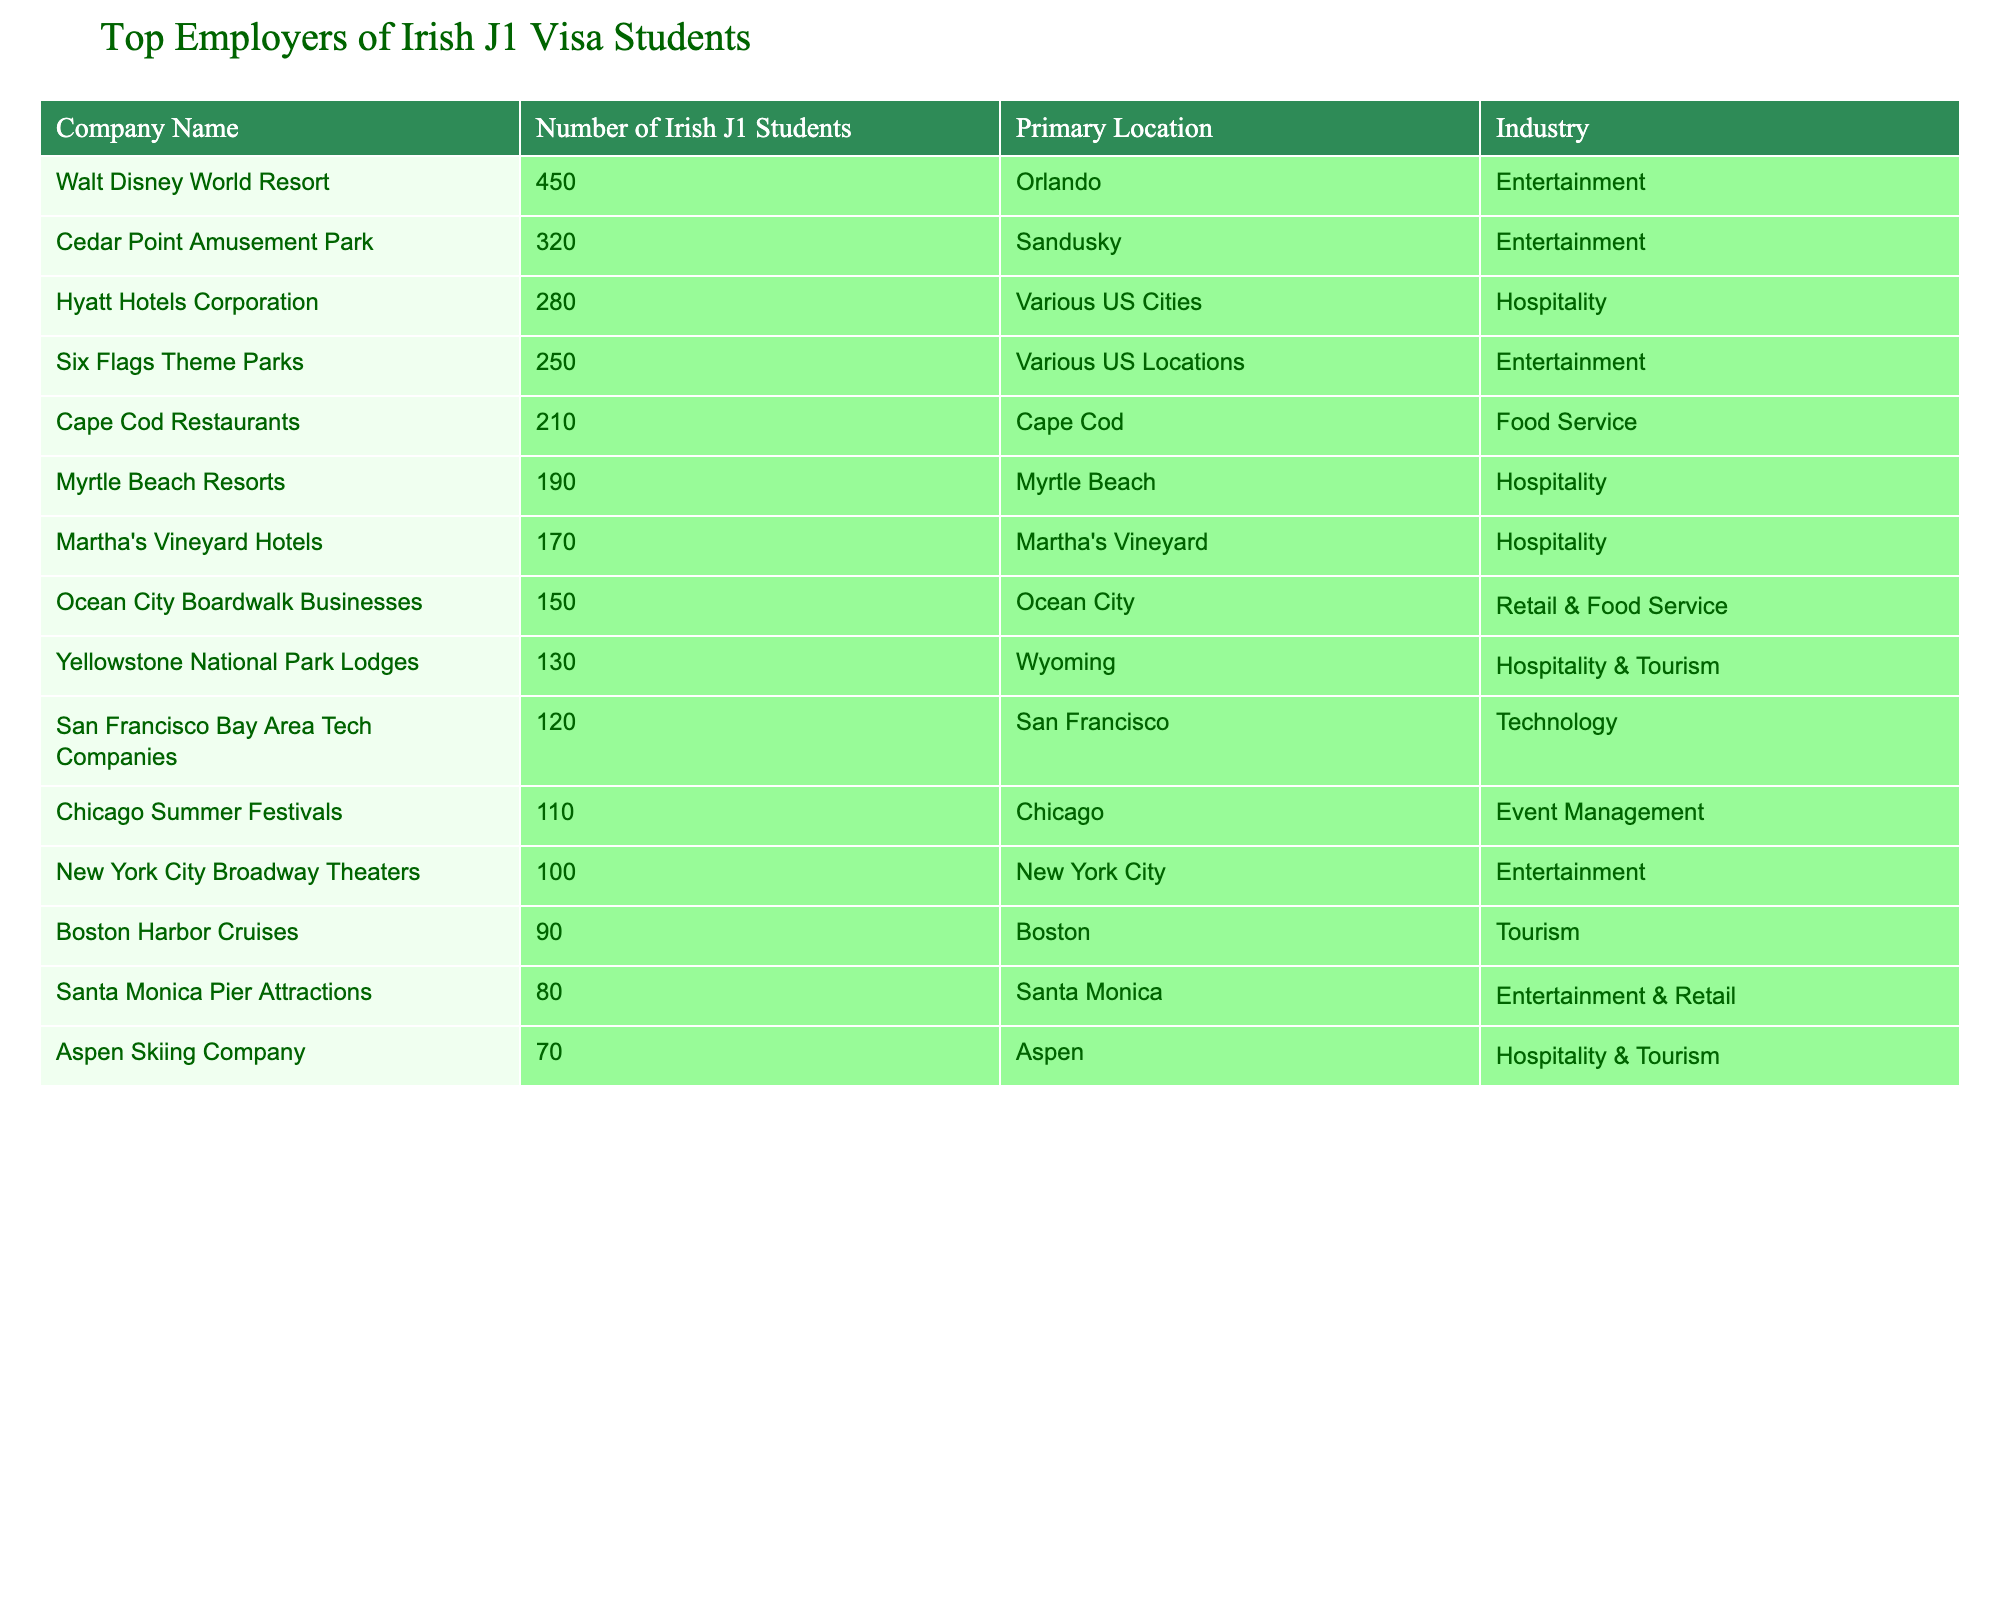What is the company with the highest number of Irish J1 students? The table shows that Walt Disney World Resort has the highest number of Irish J1 students, with a total of 450.
Answer: Walt Disney World Resort Which company is located in San Francisco? According to the table, the company located in San Francisco is San Francisco Bay Area Tech Companies, which employs 120 Irish J1 students.
Answer: San Francisco Bay Area Tech Companies How many Irish J1 students are employed by Cedar Point Amusement Park? The table lists Cedar Point Amusement Park with 320 Irish J1 students.
Answer: 320 What is the total number of J1 students from Ireland employed by the hospitality industry? The hospitality industry includes Hyatt Hotels Corporation, Myrtle Beach Resorts, Martha's Vineyard Hotels, Yellowstone National Park Lodges, and Aspen Skiing Company. Summing them gives 280 + 190 + 170 + 130 + 70 = 840.
Answer: 840 Are there more J1 students in entertainment or hospitality? Entertainment has a total of 450 + 320 + 250 + 100 + 80 = 1200 J1 students, while hospitality has 840 J1 students. Since 1200 is greater than 840, entertainment has more J1 students.
Answer: Yes, entertainment has more J1 students What percentage of the total J1 students in the table are from Walt Disney World Resort? The total number of J1 students is 450 + 320 + 280 + 250 + 210 + 190 + 170 + 150 + 130 + 120 + 110 + 100 + 90 + 80 + 70 = 2,330. The percentage from Walt Disney World Resort is (450/2330) * 100 ≈ 19.31%.
Answer: Approximately 19.31% Which industry has the least number of Irish J1 students, and how many are there? By analyzing the numbers, Aspen Skiing Company, located in the hospitality & tourism industry, has the least number of J1 students with 70.
Answer: Hospitality & Tourism with 70 J1 students If you combine the numbers of J1 students from Ocean City Boardwalk Businesses and Cape Cod Restaurants, what will the total be? Ocean City Boardwalk Businesses has 150 J1 students, and Cape Cod Restaurants has 210. Adding these gives 150 + 210 = 360.
Answer: 360 How many Irish J1 students are employed in the tech industry? The table shows that there are 120 J1 students employed by San Francisco Bay Area Tech Companies, which is the only listed company in the technology sector.
Answer: 120 If the combined number of J1 students at Six Flags Theme Parks and New York City Broadway Theaters were to decrease by 20, how many would remain? Six Flags Theme Parks has 250 J1 students and New York City Broadway Theaters has 100. Their combined total is 250 + 100 = 350. If we decrease this by 20, it equals 350 - 20 = 330.
Answer: 330 